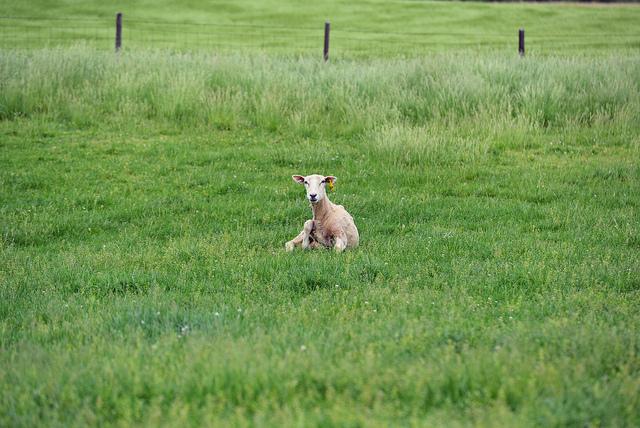What animal is pictured?
Concise answer only. Lamb. What is the animal laying in?
Concise answer only. Grass. What color is the fence?
Keep it brief. Brown. How many poles do you see for the fence?
Be succinct. 3. Which animal is in the photo?
Keep it brief. Sheep. 